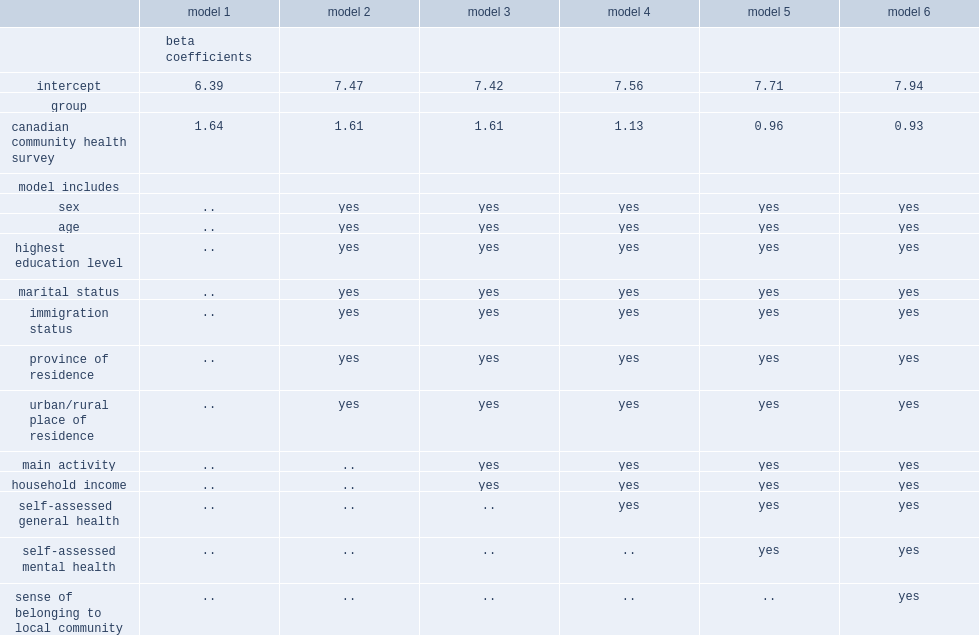In the absence of any other covariates, how much was life satisfaction higher among cchs respondents compared with carrot respondents, on a scale from 0 to 10? 1.64. What was the difference in life satisfaction among carrot and cchs respondents in model 4? 1.13. What was the difference in life satisfaction among carrot and cchs respondents in model 5? 0.96. What was the difference in life satisfaction among carrot and cchs respondents after the inclusion of the sense of community belonging? 0.93. What was the difference in life satisfaction among carrot and cchs respondents when all well-established and strong correlates of life satisfaction were taken into account? 0.93. Would you be able to parse every entry in this table? {'header': ['', 'model 1', 'model 2', 'model 3', 'model 4', 'model 5', 'model 6'], 'rows': [['', 'beta coefficients', '', '', '', '', ''], ['intercept', '6.39', '7.47', '7.42', '7.56', '7.71', '7.94'], ['group', '', '', '', '', '', ''], ['canadian community health survey', '1.64', '1.61', '1.61', '1.13', '0.96', '0.93'], ['model includes', '', '', '', '', '', ''], ['sex', '..', 'yes', 'yes', 'yes', 'yes', 'yes'], ['age', '..', 'yes', 'yes', 'yes', 'yes', 'yes'], ['highest education level', '..', 'yes', 'yes', 'yes', 'yes', 'yes'], ['marital status', '..', 'yes', 'yes', 'yes', 'yes', 'yes'], ['immigration status', '..', 'yes', 'yes', 'yes', 'yes', 'yes'], ['province of residence', '..', 'yes', 'yes', 'yes', 'yes', 'yes'], ['urban/rural place of residence', '..', 'yes', 'yes', 'yes', 'yes', 'yes'], ['main activity', '..', '..', 'yes', 'yes', 'yes', 'yes'], ['household income', '..', '..', 'yes', 'yes', 'yes', 'yes'], ['self-assessed general health', '..', '..', '..', 'yes', 'yes', 'yes'], ['self-assessed mental health', '..', '..', '..', '..', 'yes', 'yes'], ['sense of belonging to local community', '..', '..', '..', '..', '..', 'yes']]} 